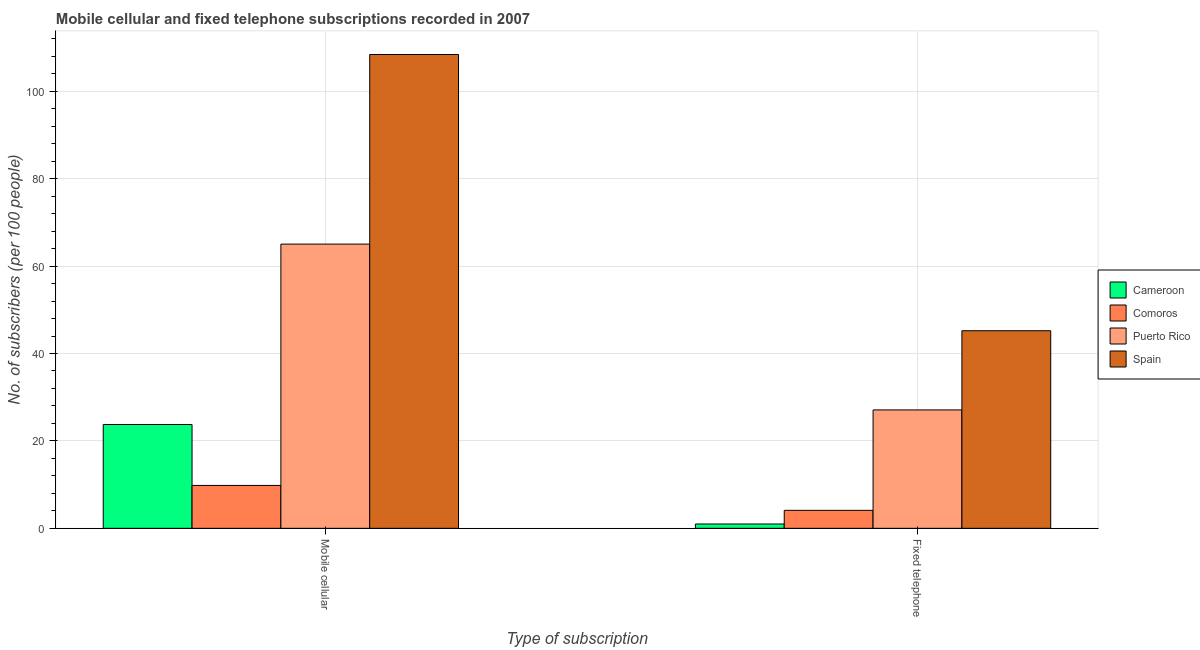How many different coloured bars are there?
Offer a terse response. 4. How many groups of bars are there?
Make the answer very short. 2. How many bars are there on the 2nd tick from the right?
Your response must be concise. 4. What is the label of the 1st group of bars from the left?
Ensure brevity in your answer.  Mobile cellular. What is the number of mobile cellular subscribers in Spain?
Give a very brief answer. 108.41. Across all countries, what is the maximum number of fixed telephone subscribers?
Offer a terse response. 45.21. Across all countries, what is the minimum number of fixed telephone subscribers?
Provide a short and direct response. 0.99. In which country was the number of fixed telephone subscribers minimum?
Your answer should be very brief. Cameroon. What is the total number of fixed telephone subscribers in the graph?
Provide a short and direct response. 77.4. What is the difference between the number of fixed telephone subscribers in Puerto Rico and that in Spain?
Keep it short and to the point. -18.12. What is the difference between the number of fixed telephone subscribers in Cameroon and the number of mobile cellular subscribers in Spain?
Provide a succinct answer. -107.43. What is the average number of mobile cellular subscribers per country?
Offer a very short reply. 51.75. What is the difference between the number of mobile cellular subscribers and number of fixed telephone subscribers in Puerto Rico?
Give a very brief answer. 37.94. What is the ratio of the number of fixed telephone subscribers in Cameroon to that in Spain?
Provide a short and direct response. 0.02. Is the number of fixed telephone subscribers in Comoros less than that in Puerto Rico?
Keep it short and to the point. Yes. In how many countries, is the number of mobile cellular subscribers greater than the average number of mobile cellular subscribers taken over all countries?
Your answer should be compact. 2. What does the 3rd bar from the left in Fixed telephone represents?
Your response must be concise. Puerto Rico. What does the 3rd bar from the right in Mobile cellular represents?
Provide a short and direct response. Comoros. How many bars are there?
Your answer should be very brief. 8. How many legend labels are there?
Ensure brevity in your answer.  4. What is the title of the graph?
Offer a very short reply. Mobile cellular and fixed telephone subscriptions recorded in 2007. Does "Mexico" appear as one of the legend labels in the graph?
Your response must be concise. No. What is the label or title of the X-axis?
Make the answer very short. Type of subscription. What is the label or title of the Y-axis?
Ensure brevity in your answer.  No. of subscribers (per 100 people). What is the No. of subscribers (per 100 people) in Cameroon in Mobile cellular?
Your answer should be very brief. 23.75. What is the No. of subscribers (per 100 people) of Comoros in Mobile cellular?
Provide a succinct answer. 9.82. What is the No. of subscribers (per 100 people) in Puerto Rico in Mobile cellular?
Your answer should be very brief. 65.03. What is the No. of subscribers (per 100 people) in Spain in Mobile cellular?
Offer a terse response. 108.41. What is the No. of subscribers (per 100 people) of Cameroon in Fixed telephone?
Keep it short and to the point. 0.99. What is the No. of subscribers (per 100 people) of Comoros in Fixed telephone?
Provide a short and direct response. 4.11. What is the No. of subscribers (per 100 people) of Puerto Rico in Fixed telephone?
Provide a short and direct response. 27.09. What is the No. of subscribers (per 100 people) in Spain in Fixed telephone?
Offer a terse response. 45.21. Across all Type of subscription, what is the maximum No. of subscribers (per 100 people) of Cameroon?
Offer a terse response. 23.75. Across all Type of subscription, what is the maximum No. of subscribers (per 100 people) of Comoros?
Make the answer very short. 9.82. Across all Type of subscription, what is the maximum No. of subscribers (per 100 people) of Puerto Rico?
Your response must be concise. 65.03. Across all Type of subscription, what is the maximum No. of subscribers (per 100 people) of Spain?
Provide a succinct answer. 108.41. Across all Type of subscription, what is the minimum No. of subscribers (per 100 people) in Cameroon?
Offer a terse response. 0.99. Across all Type of subscription, what is the minimum No. of subscribers (per 100 people) in Comoros?
Offer a terse response. 4.11. Across all Type of subscription, what is the minimum No. of subscribers (per 100 people) in Puerto Rico?
Provide a succinct answer. 27.09. Across all Type of subscription, what is the minimum No. of subscribers (per 100 people) in Spain?
Give a very brief answer. 45.21. What is the total No. of subscribers (per 100 people) in Cameroon in the graph?
Keep it short and to the point. 24.74. What is the total No. of subscribers (per 100 people) of Comoros in the graph?
Your response must be concise. 13.93. What is the total No. of subscribers (per 100 people) in Puerto Rico in the graph?
Make the answer very short. 92.13. What is the total No. of subscribers (per 100 people) in Spain in the graph?
Your response must be concise. 153.62. What is the difference between the No. of subscribers (per 100 people) in Cameroon in Mobile cellular and that in Fixed telephone?
Ensure brevity in your answer.  22.76. What is the difference between the No. of subscribers (per 100 people) of Comoros in Mobile cellular and that in Fixed telephone?
Make the answer very short. 5.7. What is the difference between the No. of subscribers (per 100 people) of Puerto Rico in Mobile cellular and that in Fixed telephone?
Offer a very short reply. 37.94. What is the difference between the No. of subscribers (per 100 people) of Spain in Mobile cellular and that in Fixed telephone?
Ensure brevity in your answer.  63.21. What is the difference between the No. of subscribers (per 100 people) of Cameroon in Mobile cellular and the No. of subscribers (per 100 people) of Comoros in Fixed telephone?
Give a very brief answer. 19.64. What is the difference between the No. of subscribers (per 100 people) in Cameroon in Mobile cellular and the No. of subscribers (per 100 people) in Puerto Rico in Fixed telephone?
Your answer should be compact. -3.34. What is the difference between the No. of subscribers (per 100 people) of Cameroon in Mobile cellular and the No. of subscribers (per 100 people) of Spain in Fixed telephone?
Give a very brief answer. -21.46. What is the difference between the No. of subscribers (per 100 people) in Comoros in Mobile cellular and the No. of subscribers (per 100 people) in Puerto Rico in Fixed telephone?
Your response must be concise. -17.28. What is the difference between the No. of subscribers (per 100 people) of Comoros in Mobile cellular and the No. of subscribers (per 100 people) of Spain in Fixed telephone?
Offer a terse response. -35.39. What is the difference between the No. of subscribers (per 100 people) in Puerto Rico in Mobile cellular and the No. of subscribers (per 100 people) in Spain in Fixed telephone?
Offer a terse response. 19.82. What is the average No. of subscribers (per 100 people) in Cameroon per Type of subscription?
Provide a succinct answer. 12.37. What is the average No. of subscribers (per 100 people) of Comoros per Type of subscription?
Provide a short and direct response. 6.96. What is the average No. of subscribers (per 100 people) of Puerto Rico per Type of subscription?
Your response must be concise. 46.06. What is the average No. of subscribers (per 100 people) of Spain per Type of subscription?
Your answer should be compact. 76.81. What is the difference between the No. of subscribers (per 100 people) of Cameroon and No. of subscribers (per 100 people) of Comoros in Mobile cellular?
Make the answer very short. 13.94. What is the difference between the No. of subscribers (per 100 people) in Cameroon and No. of subscribers (per 100 people) in Puerto Rico in Mobile cellular?
Provide a short and direct response. -41.28. What is the difference between the No. of subscribers (per 100 people) of Cameroon and No. of subscribers (per 100 people) of Spain in Mobile cellular?
Your answer should be very brief. -84.66. What is the difference between the No. of subscribers (per 100 people) in Comoros and No. of subscribers (per 100 people) in Puerto Rico in Mobile cellular?
Keep it short and to the point. -55.22. What is the difference between the No. of subscribers (per 100 people) of Comoros and No. of subscribers (per 100 people) of Spain in Mobile cellular?
Provide a short and direct response. -98.6. What is the difference between the No. of subscribers (per 100 people) of Puerto Rico and No. of subscribers (per 100 people) of Spain in Mobile cellular?
Give a very brief answer. -43.38. What is the difference between the No. of subscribers (per 100 people) in Cameroon and No. of subscribers (per 100 people) in Comoros in Fixed telephone?
Provide a succinct answer. -3.12. What is the difference between the No. of subscribers (per 100 people) in Cameroon and No. of subscribers (per 100 people) in Puerto Rico in Fixed telephone?
Offer a terse response. -26.1. What is the difference between the No. of subscribers (per 100 people) of Cameroon and No. of subscribers (per 100 people) of Spain in Fixed telephone?
Make the answer very short. -44.22. What is the difference between the No. of subscribers (per 100 people) in Comoros and No. of subscribers (per 100 people) in Puerto Rico in Fixed telephone?
Offer a terse response. -22.98. What is the difference between the No. of subscribers (per 100 people) of Comoros and No. of subscribers (per 100 people) of Spain in Fixed telephone?
Your response must be concise. -41.1. What is the difference between the No. of subscribers (per 100 people) in Puerto Rico and No. of subscribers (per 100 people) in Spain in Fixed telephone?
Ensure brevity in your answer.  -18.12. What is the ratio of the No. of subscribers (per 100 people) of Cameroon in Mobile cellular to that in Fixed telephone?
Ensure brevity in your answer.  24.02. What is the ratio of the No. of subscribers (per 100 people) of Comoros in Mobile cellular to that in Fixed telephone?
Your response must be concise. 2.39. What is the ratio of the No. of subscribers (per 100 people) in Puerto Rico in Mobile cellular to that in Fixed telephone?
Keep it short and to the point. 2.4. What is the ratio of the No. of subscribers (per 100 people) in Spain in Mobile cellular to that in Fixed telephone?
Ensure brevity in your answer.  2.4. What is the difference between the highest and the second highest No. of subscribers (per 100 people) of Cameroon?
Your answer should be very brief. 22.76. What is the difference between the highest and the second highest No. of subscribers (per 100 people) in Comoros?
Keep it short and to the point. 5.7. What is the difference between the highest and the second highest No. of subscribers (per 100 people) in Puerto Rico?
Your response must be concise. 37.94. What is the difference between the highest and the second highest No. of subscribers (per 100 people) of Spain?
Your answer should be very brief. 63.21. What is the difference between the highest and the lowest No. of subscribers (per 100 people) of Cameroon?
Your answer should be compact. 22.76. What is the difference between the highest and the lowest No. of subscribers (per 100 people) of Comoros?
Offer a very short reply. 5.7. What is the difference between the highest and the lowest No. of subscribers (per 100 people) in Puerto Rico?
Offer a terse response. 37.94. What is the difference between the highest and the lowest No. of subscribers (per 100 people) in Spain?
Offer a very short reply. 63.21. 